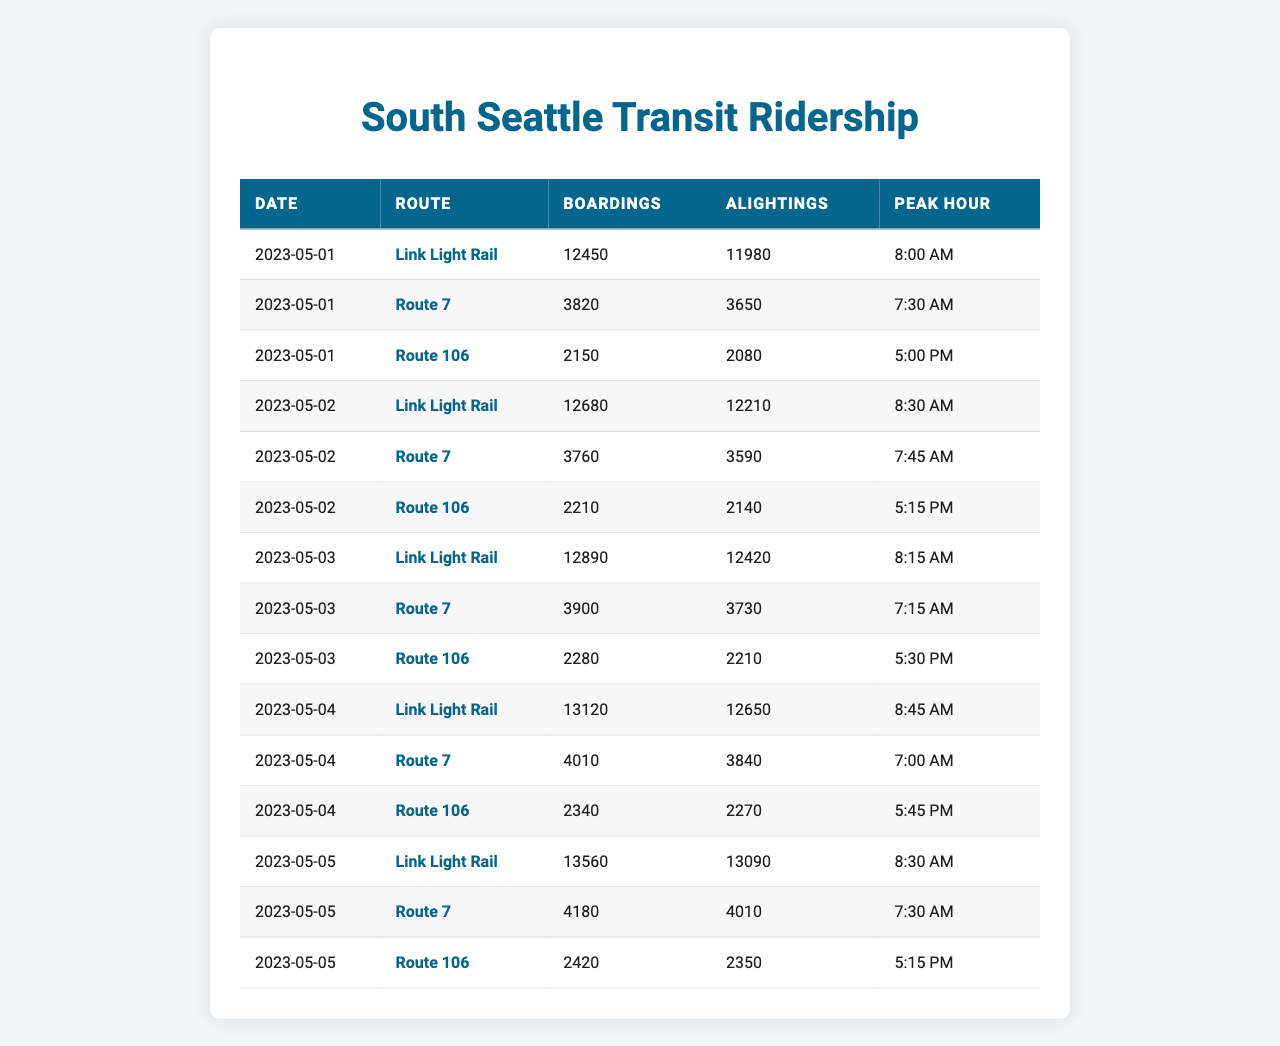What is the total number of boardings for the Link Light Rail on May 5, 2023? Referring to the table, the boardings for the Link Light Rail on May 5, 2023, is 13,560.
Answer: 13560 Which route had the highest alightings on May 4, 2023? Looking at the alightings on May 4, 2023, the Link Light Rail had the highest with 12,650.
Answer: Link Light Rail What is the peak hour for Route 7 on May 3, 2023? From the table, for Route 7 on May 3, 2023, the peak hour is listed as 7:15 AM.
Answer: 7:15 AM How many more boardings did Route 106 have on May 5 compared to May 1? On May 5, Route 106 had 2,420 boardings, and on May 1 it had 2,150. The difference is 2,420 - 2,150 = 270.
Answer: 270 What is the average number of boardings for Route 7 over the five days? The boardings for Route 7 over the five days are 3,820, 3,760, 3,900, 4,010, and 4,180. Summing these gives 19,670, and dividing by 5 gives an average of 3,934.
Answer: 3934 Did the Link Light Rail have more boardings on May 2 than Route 106 on the same day? On May 2, Link Light Rail had 12,680 boardings while Route 106 had 2,210. Since 12,680 is greater than 2,210, the statement is true.
Answer: Yes What is the total number of alightings for all routes on May 1, 2023? Alightings on May 1 for all routes are 11,980 (Link Light Rail) + 3,650 (Route 7) + 2,080 (Route 106) = 17,710.
Answer: 17710 Which route had the highest total boardings over the five days? By summing up each route's boardings: Link Light Rail had 65,490, Route 7 had 19,670, and Route 106 had 11,450. Link Light Rail has the highest total with 65,490.
Answer: Link Light Rail What was the peak hour for Route 106 on May 3, 2023? For Route 106 on May 3, the peak hour is noted as 5:30 PM.
Answer: 5:30 PM What is the variance in boardings for the Link Light Rail across the five days? Calculating the boardings gives values of 12,450, 12,680, 12,890, 13,120, and 13,560. The mean is 12,830 and calculating the squared differences gives a variance of approximately 731.
Answer: 731 